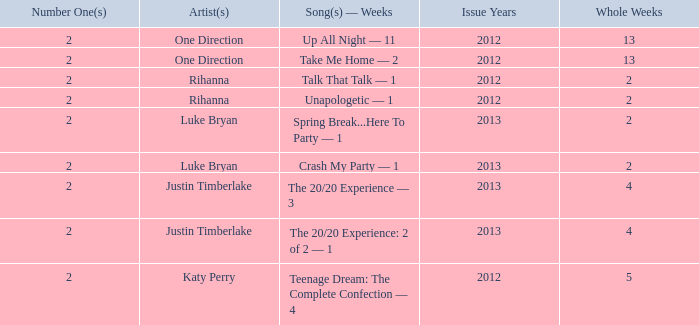What is the title of every song, and how many weeks was each song at #1 for Rihanna in 2012? Talk That Talk — 1, Unapologetic — 1. 